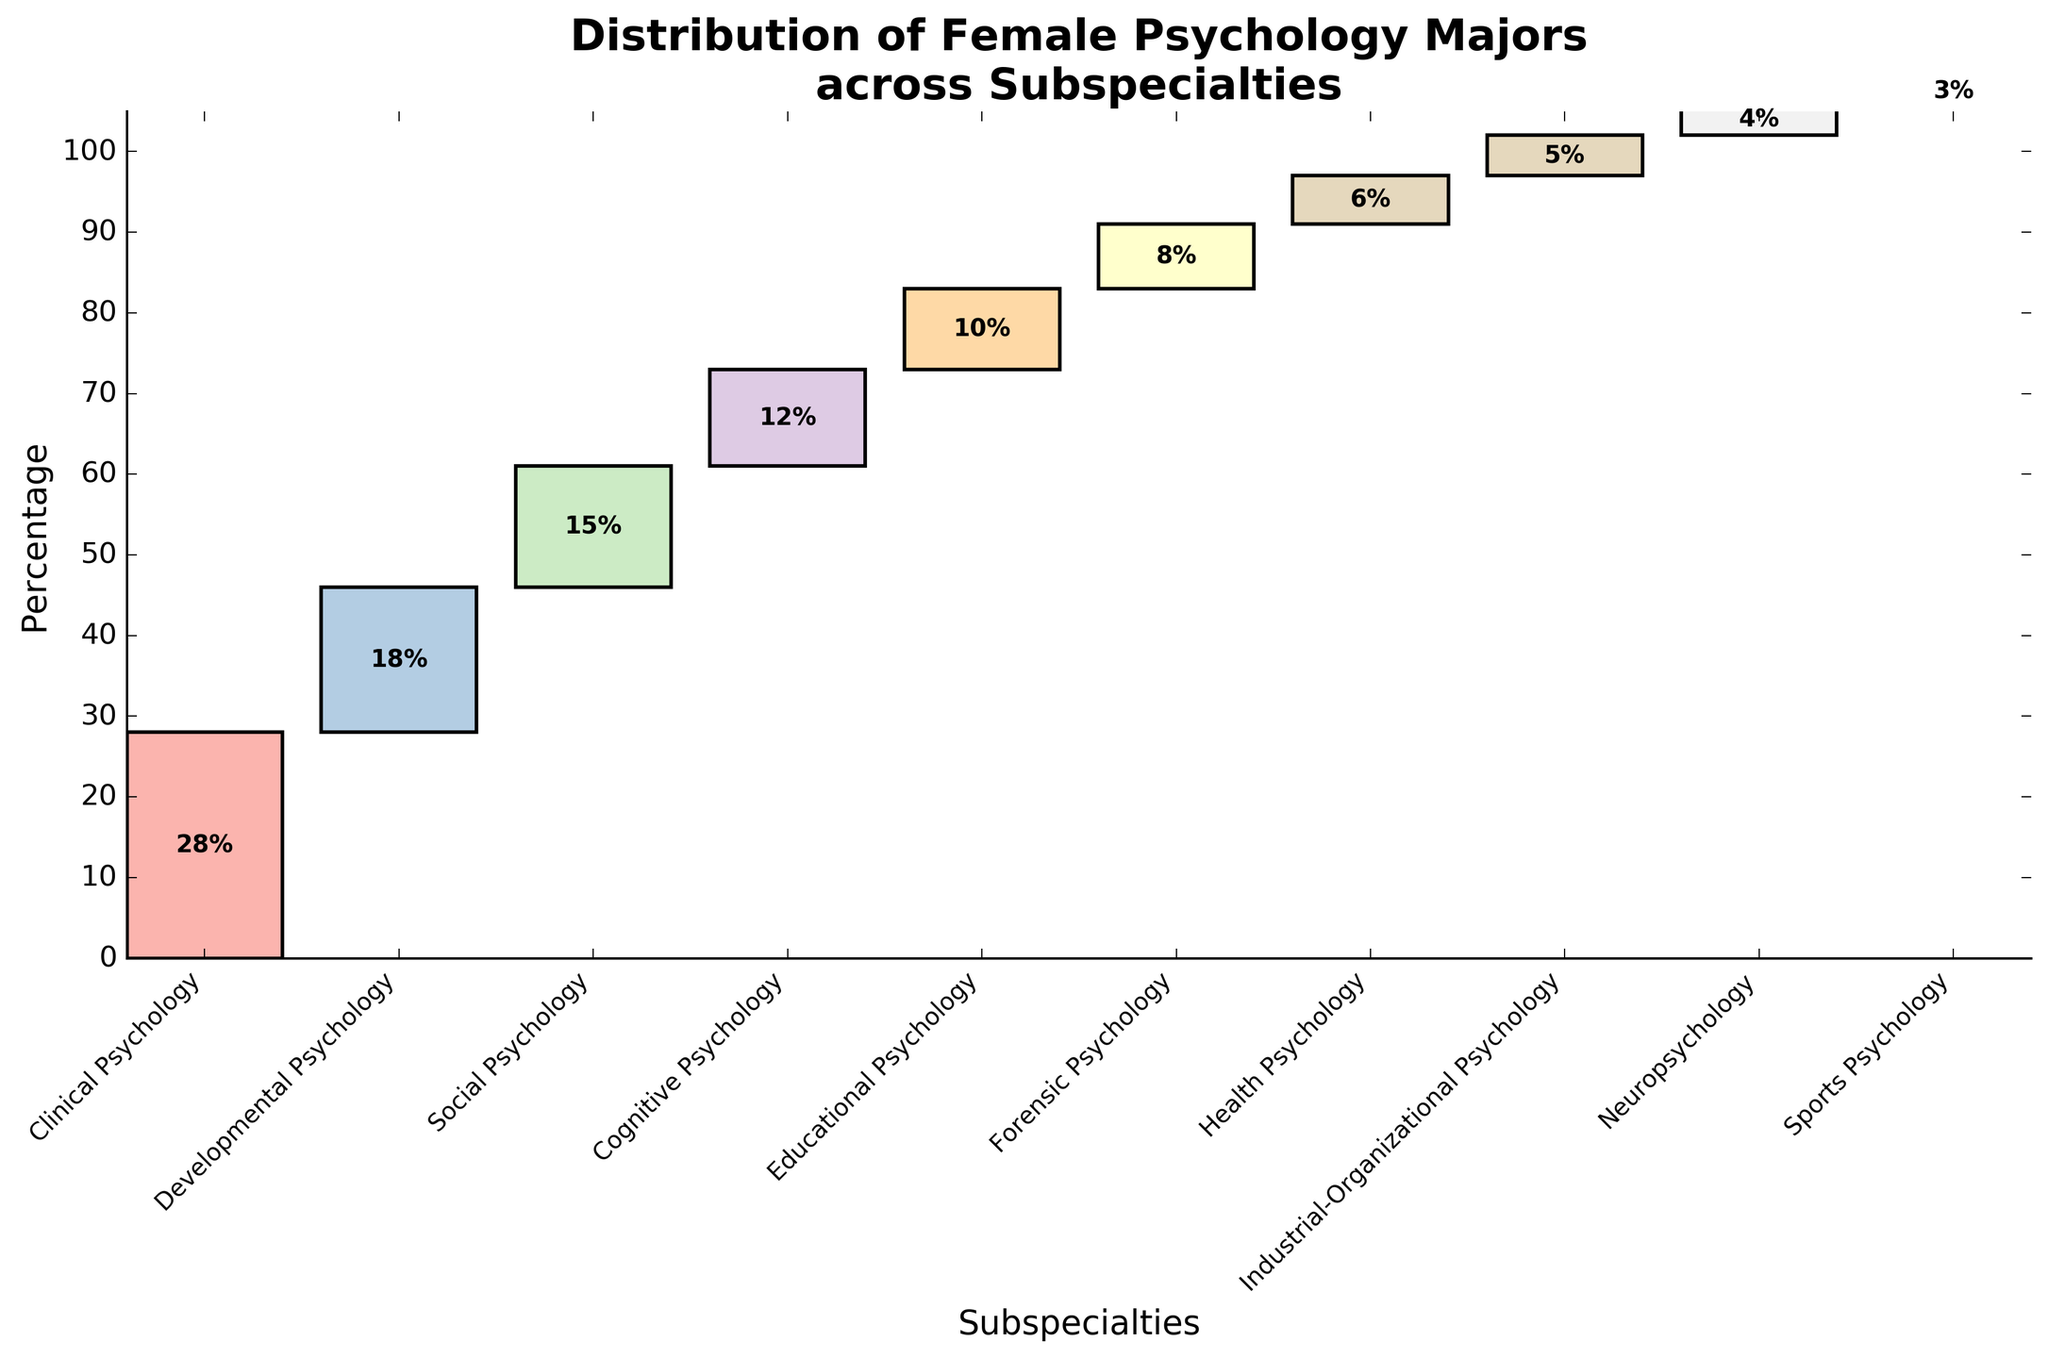What is the title of the chart? The title of the chart is written at the top of the figure.
Answer: Distribution of Female Psychology Majors across Subspecialties Which subspecialty has the highest percentage of female psychology majors? The chart displays a bar for each subspecialty, and the tallest bar represents the subspecialty with the highest percentage.
Answer: Clinical Psychology What is the percentage of female psychology majors in Forensic Psychology? The percentage is displayed on the Forensic Psychology bar in the chart.
Answer: 8% How many subspecialties have a percentage of female psychology majors greater than 10%? By examining the bars and the percentages labeled on them, the subspecialties with percentages greater than 10% can be counted.
Answer: 4 subspecialties Which subspecialty has the smallest percentage of female psychology majors? The chart displays a bar for each subspecialty, and the shortest bar represents the subspecialty with the smallest percentage.
Answer: Sports Psychology How does the percentage of female psychology majors in Social Psychology compare to Health Psychology? Compare the heights and labeled percentages of the bars for Social Psychology and Health Psychology.
Answer: Social Psychology has a higher percentage (15% vs. 6%) What is the total percentage of female psychology majors in Clinical, Developmental, and Social Psychology combined? Add the percentages for Clinical Psychology (28%), Developmental Psychology (18%), and Social Psychology (15%).
Answer: 61% Which two subspecialties have a combined percentage equal to that of Educational Psychology? Find the two subspecialties whose percentages add up to the percentage of Educational Psychology (10%).
Answer: Health Psychology (6%) and Sports Psychology (4%) In terms of percentage, how much larger is Cognitive Psychology compared to Neuropsychology? Subtract the percentage for Neuropsychology (4%) from the percentage for Cognitive Psychology (12%).
Answer: 8% What is the cumulative percentage of female psychology majors up to and including Educational Psychology? Sum the percentages of all subspecialties up to Educational Psychology (Clinical, Developmental, Social, Cognitive, and Educational), which is 28 + 18 + 15 + 12 + 10.
Answer: 83% 